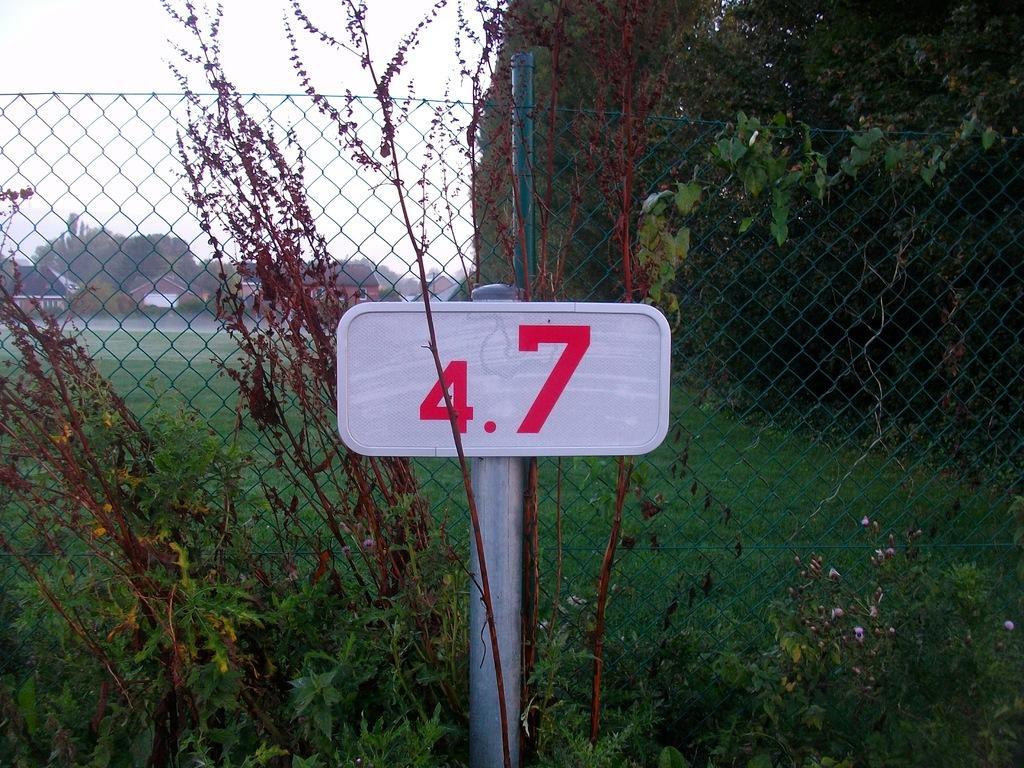Can you describe this image briefly? There is a sign board attached to the pole. On both sides of this pole, there are plants. In the background, there are is a fencing. Outside this fencing, there's grass on the ground, there are trees and there are clouds in the sky. 